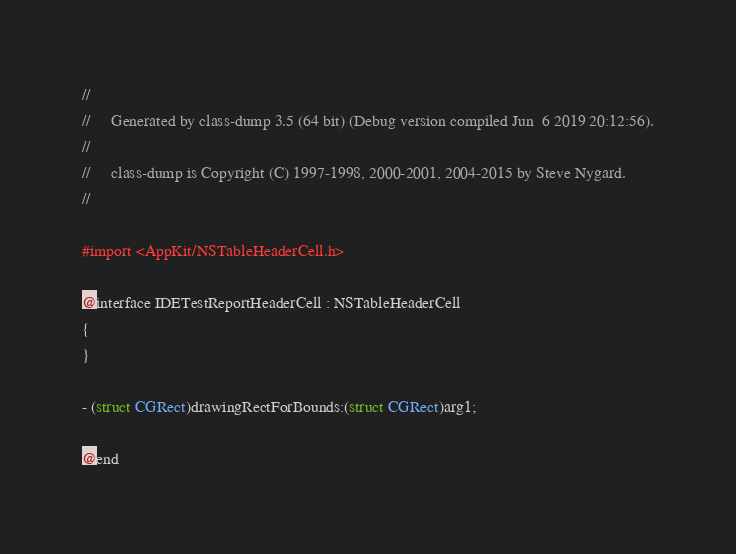<code> <loc_0><loc_0><loc_500><loc_500><_C_>//
//     Generated by class-dump 3.5 (64 bit) (Debug version compiled Jun  6 2019 20:12:56).
//
//     class-dump is Copyright (C) 1997-1998, 2000-2001, 2004-2015 by Steve Nygard.
//

#import <AppKit/NSTableHeaderCell.h>

@interface IDETestReportHeaderCell : NSTableHeaderCell
{
}

- (struct CGRect)drawingRectForBounds:(struct CGRect)arg1;

@end

</code> 